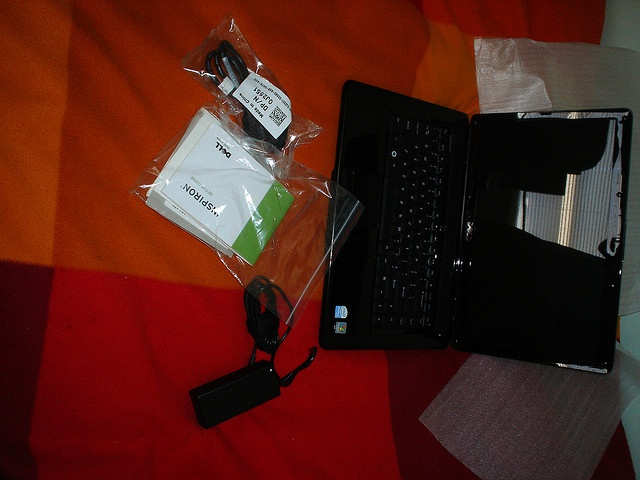Describe the objects in this image and their specific colors. I can see a laptop in maroon, black, gray, darkgray, and purple tones in this image. 